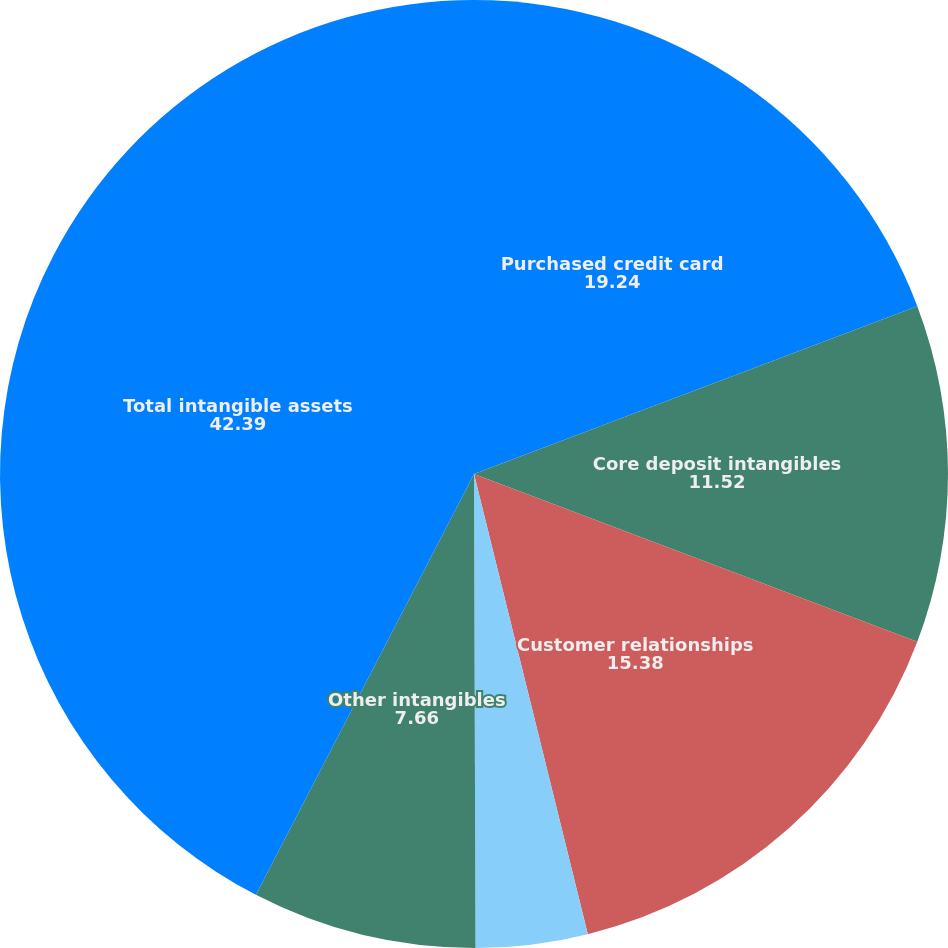<chart> <loc_0><loc_0><loc_500><loc_500><pie_chart><fcel>Purchased credit card<fcel>Core deposit intangibles<fcel>Customer relationships<fcel>Affinity relationships<fcel>Other intangibles<fcel>Total intangible assets<nl><fcel>19.24%<fcel>11.52%<fcel>15.38%<fcel>3.81%<fcel>7.66%<fcel>42.39%<nl></chart> 